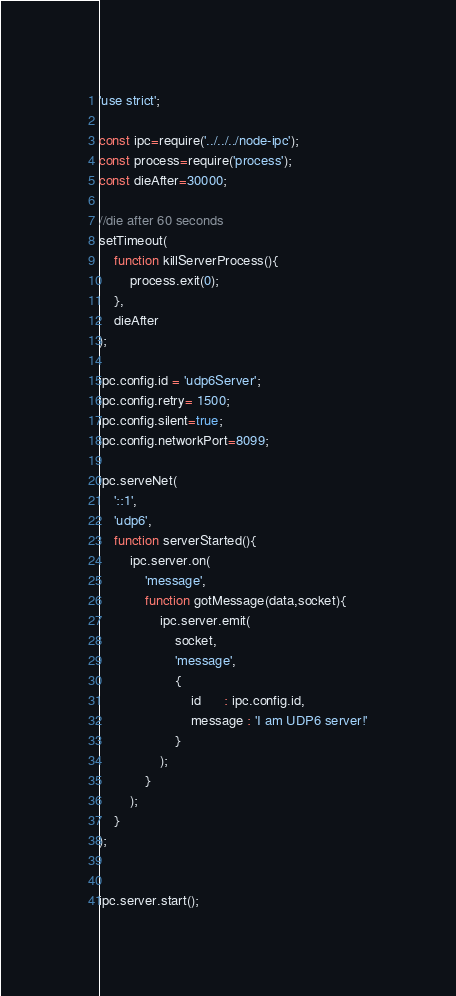Convert code to text. <code><loc_0><loc_0><loc_500><loc_500><_JavaScript_>'use strict';

const ipc=require('../../../node-ipc');
const process=require('process');
const dieAfter=30000;

//die after 60 seconds
setTimeout(
    function killServerProcess(){
        process.exit(0);
    },
    dieAfter
);

ipc.config.id = 'udp6Server';
ipc.config.retry= 1500;
ipc.config.silent=true;
ipc.config.networkPort=8099;

ipc.serveNet(
    '::1',
    'udp6',
    function serverStarted(){
        ipc.server.on(
            'message',
            function gotMessage(data,socket){
                ipc.server.emit(
                    socket,
                    'message',
                    {
                        id      : ipc.config.id,
                        message : 'I am UDP6 server!'
                    }
                );
            }
        );
    }
);


ipc.server.start();
</code> 